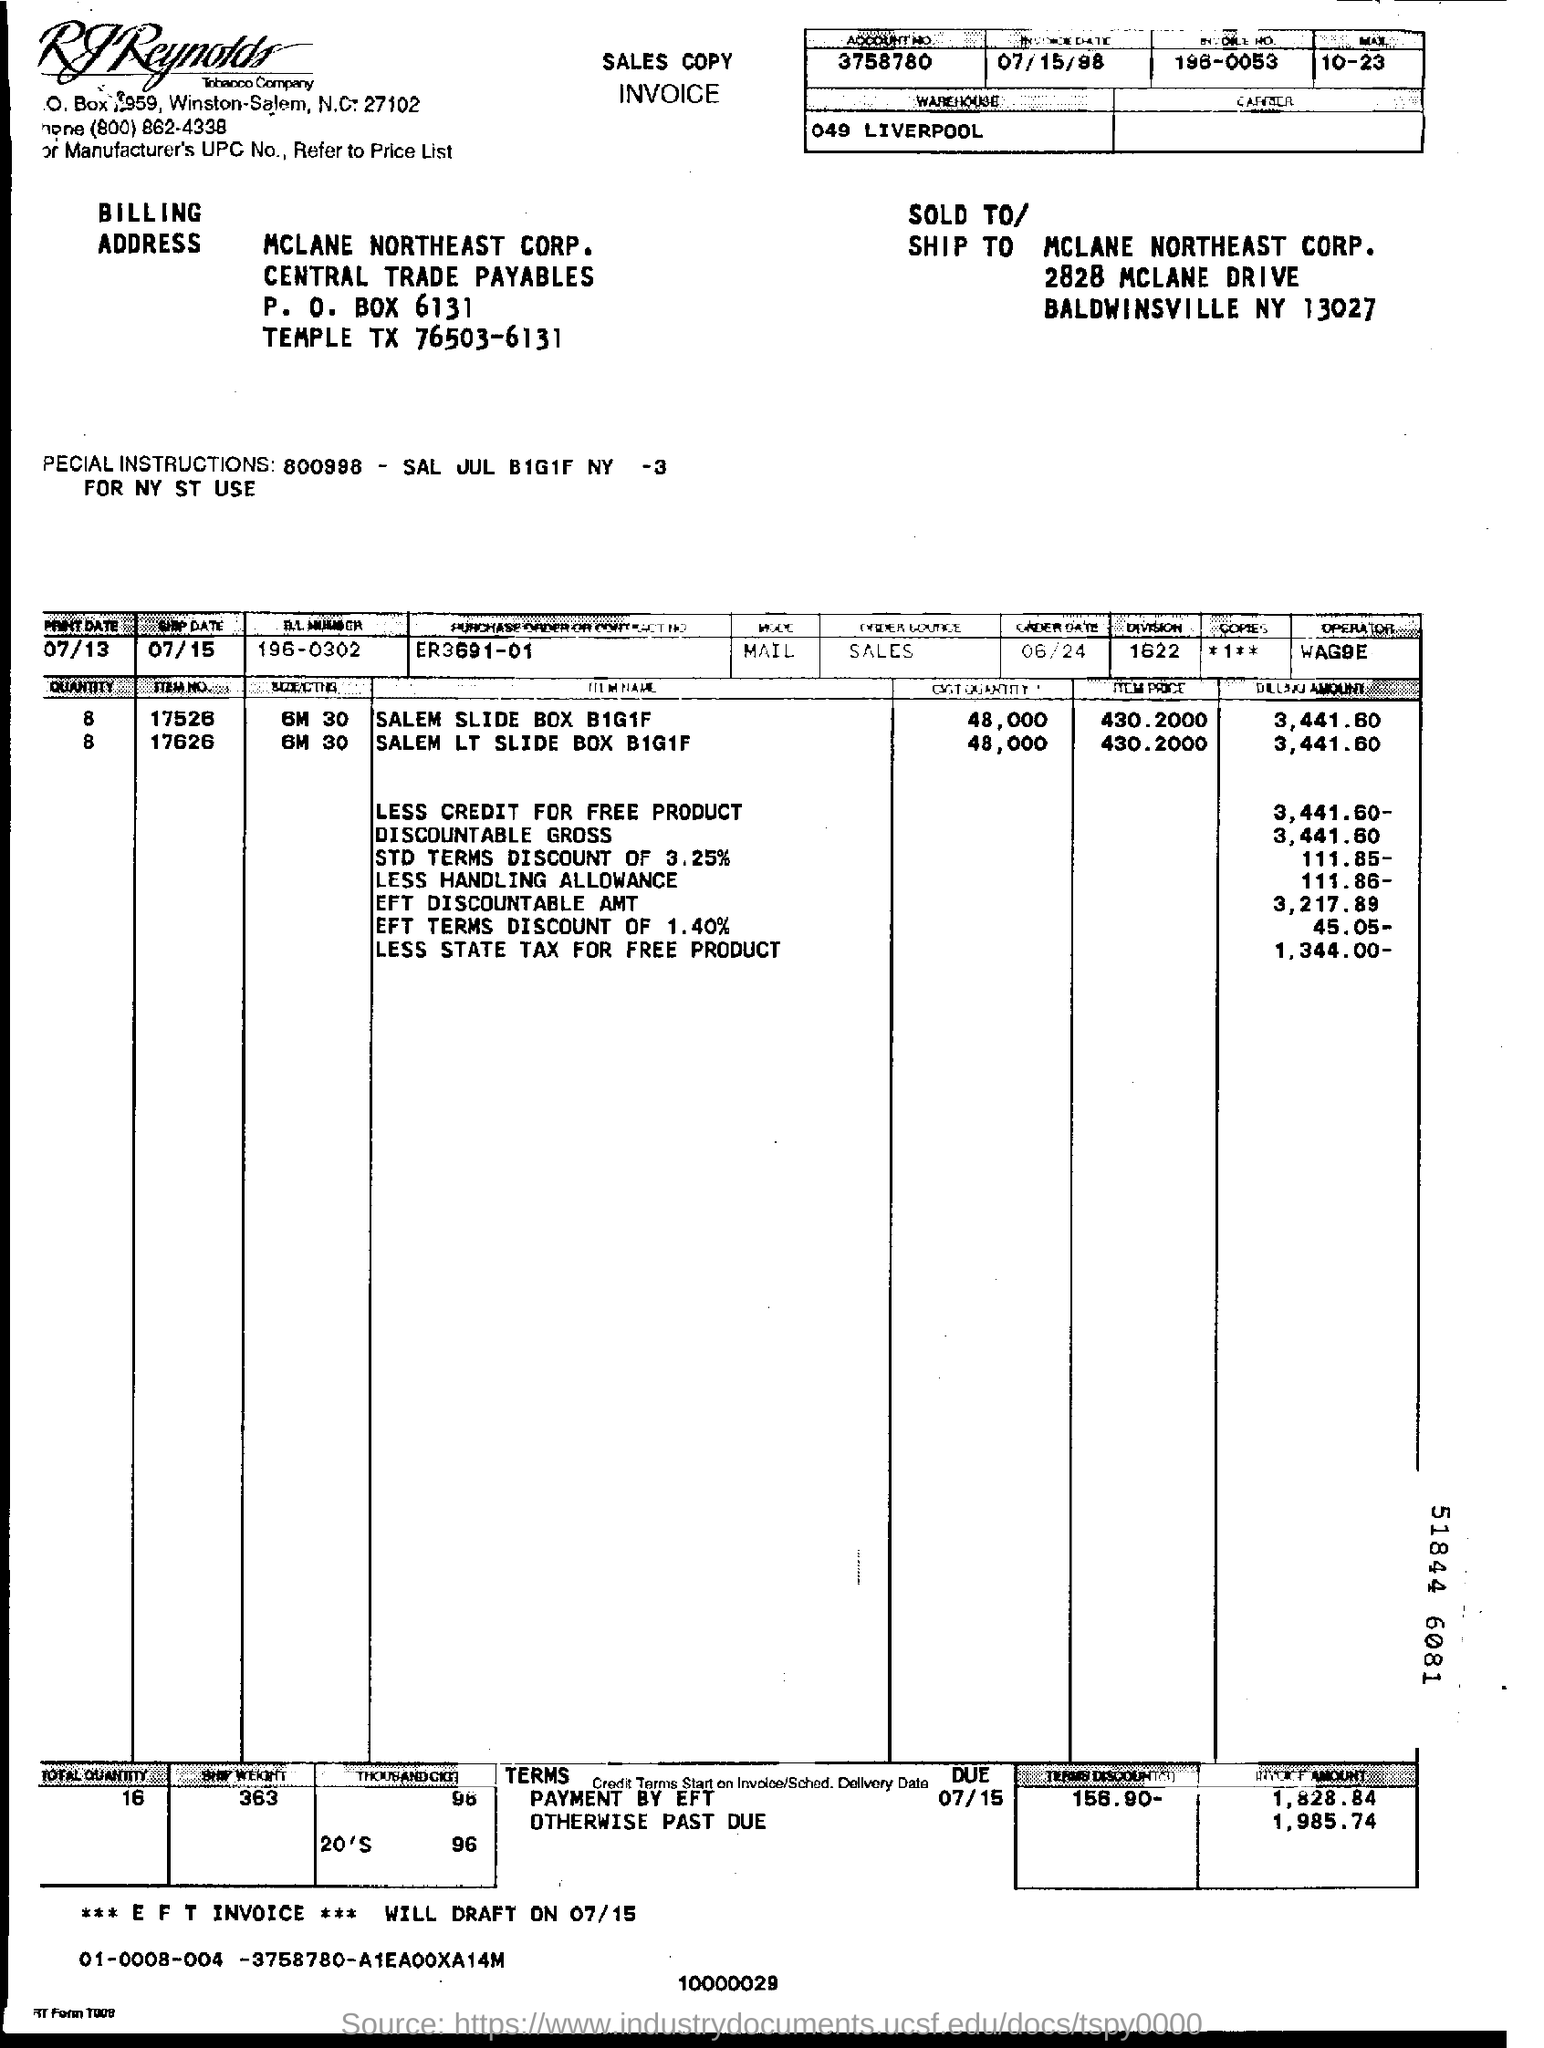What is the account number on the sales copy invoice?
Offer a very short reply. 3758780. Where is the location of warehouse?
Offer a terse response. 049 Liverpool. 